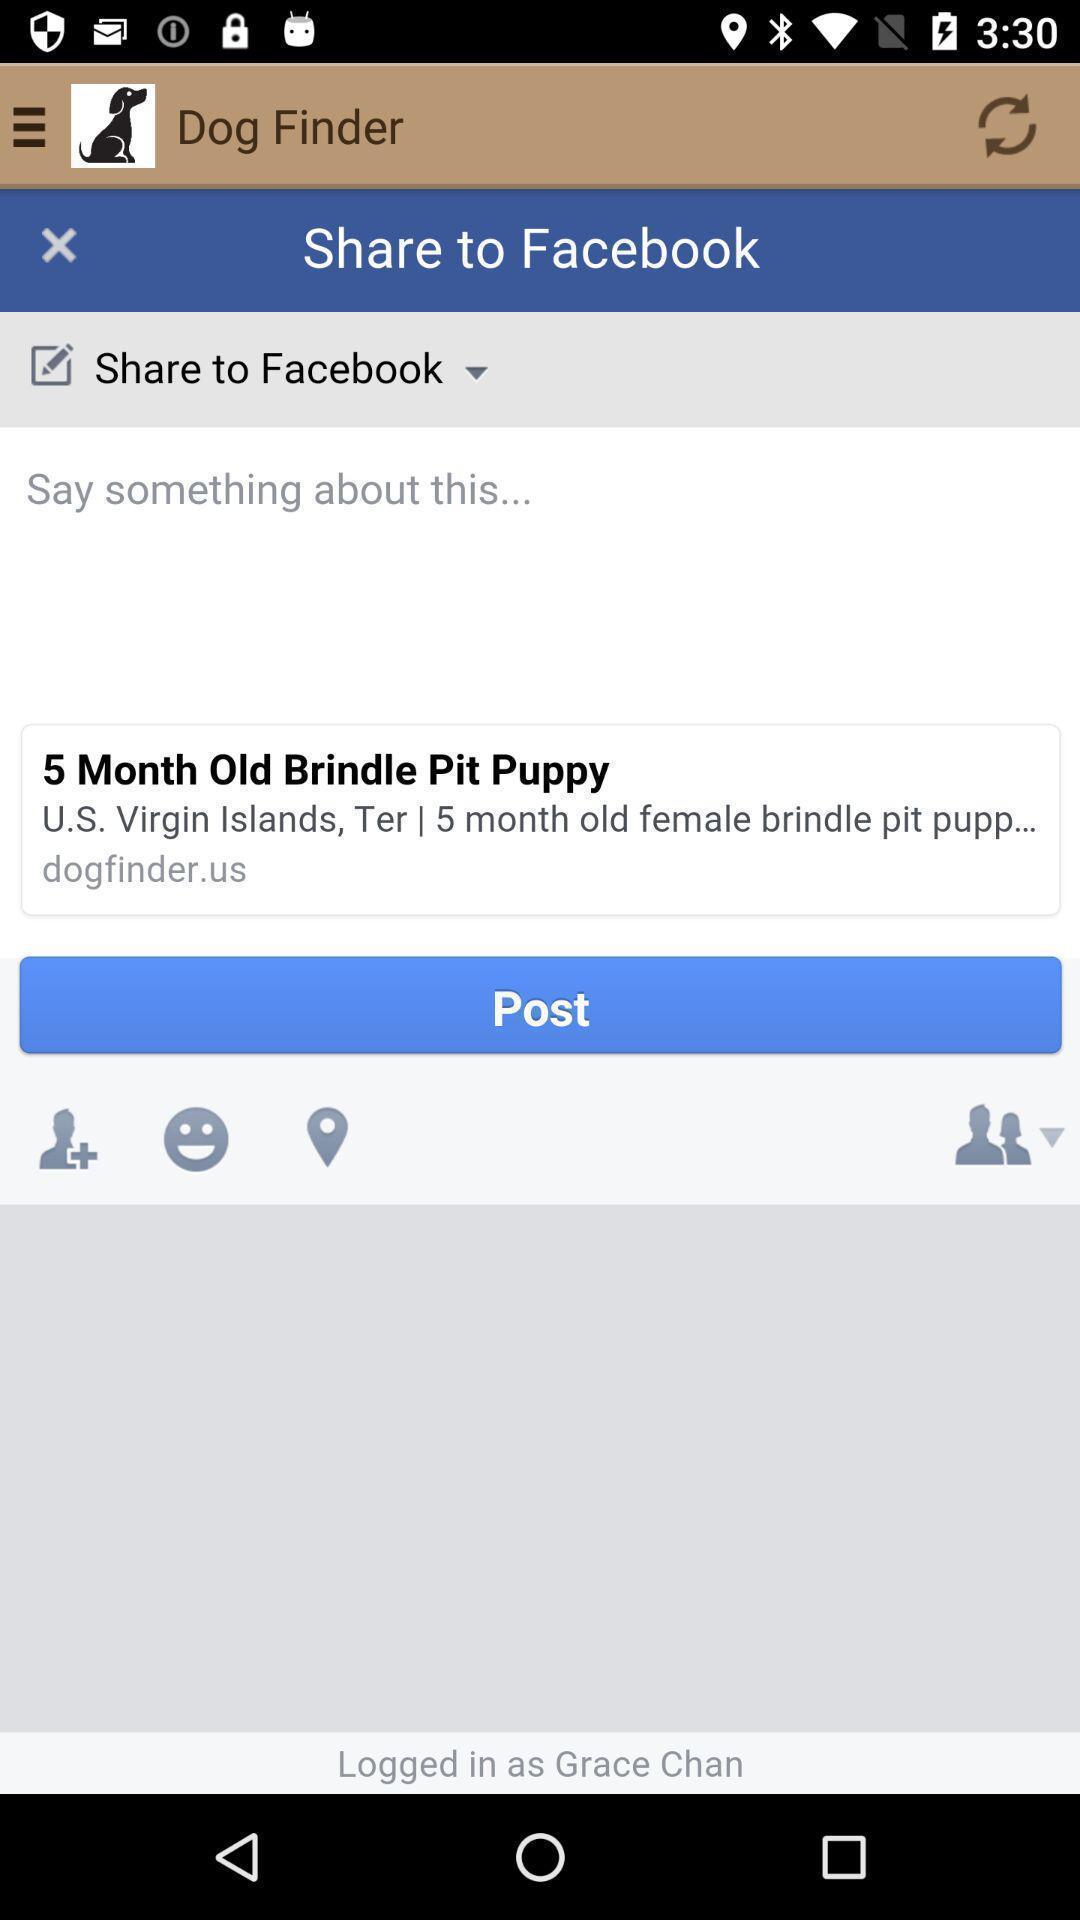Describe the key features of this screenshot. Screen showing post option with share. 